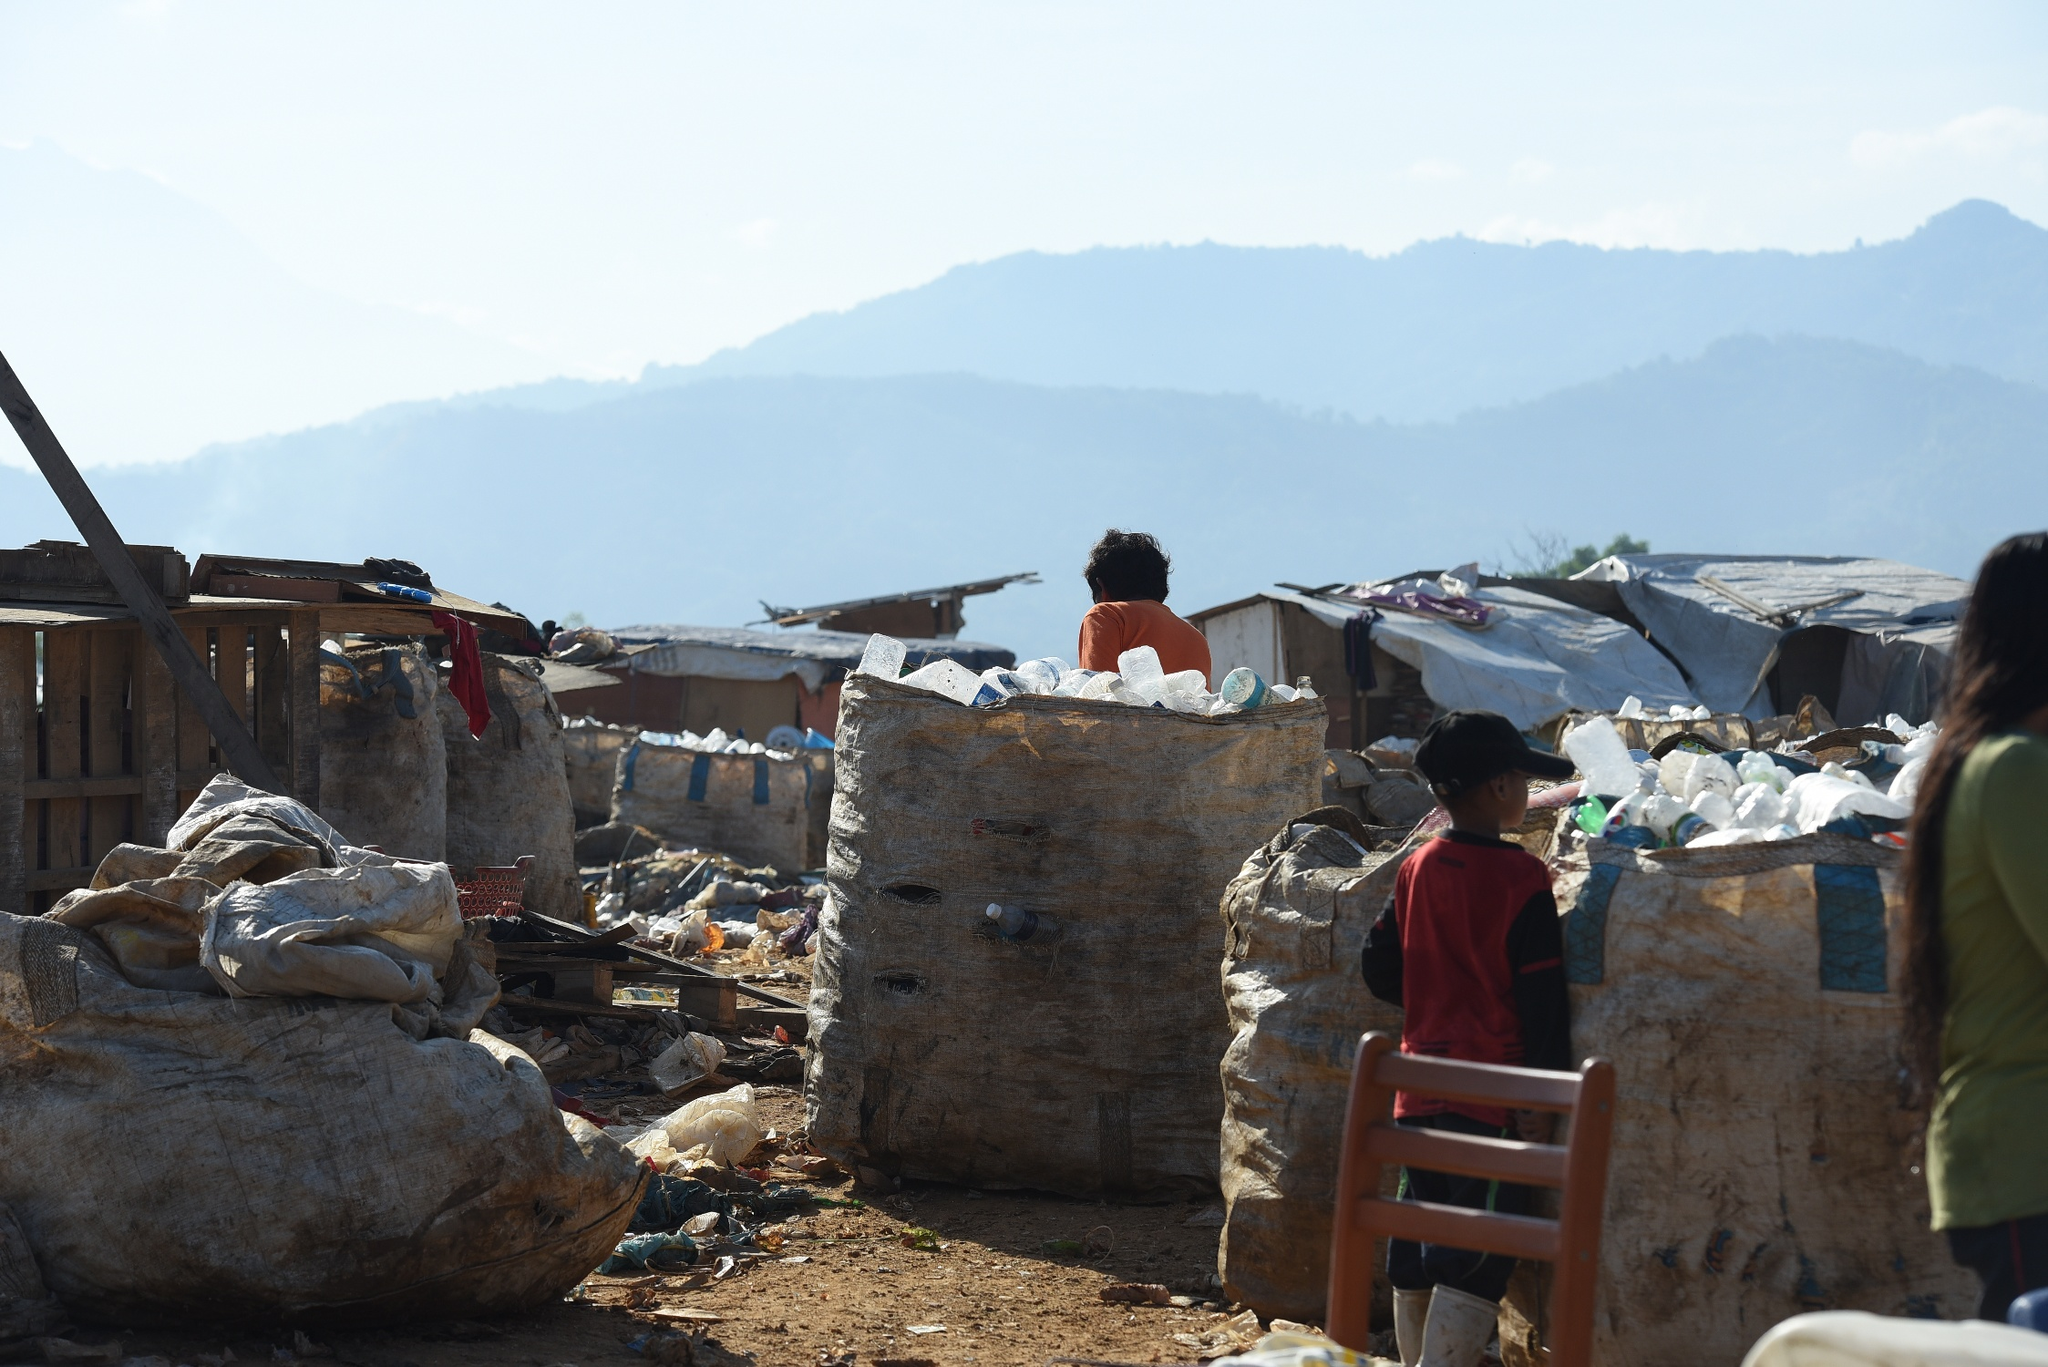Imagine a story where this child grows up and becomes a renowned environmental activist. How did their journey begin? The story begins with a young child, standing in silent contemplation beside a massive pile of discarded plastic bottles on a landfill that was once a green meadow. Witnessing the stark contrast between the serene mountains in the background and the harsh reality of the garbage-laden foreground instilled a deep sense of responsibility in the child. As they grew older, their curiosity about the causes and consequences of such environmental degradation intensified. Despite the lack of resources, the child found solace in the library's few books on nature and conservation. The defining moment came during a community clean-up drive led by a visiting environmental activist, whose stories about restoring polluted rivers inspired the child. This experience ignited a passion for environmental advocacy that saw them organizing local clean-up initiatives, campaigning for municipal recycling programs, and eventually studying environmental science. Their relentless determination and innovative approaches to waste management earned them national recognition, transforming them into a renowned environmental activist dedicated to healing the planet. As an adult activist, what significant achievements did this person accomplish? As an adult, the once curious child became a leading figure in the fight against environmental degradation, with several significant achievements to their name. They spearheaded the establishment of a nationwide plastic recycling program that drastically reduced waste in landfills. Their most notable campaign led to the clean-up and revitalization of a heavily polluted river, turning it back into a thriving ecosystem teeming with wildlife. Their advocacy work resulted in stricter environmental regulations, ensuring industries adopted greener practices and minimizing their ecological footprints. They also founded an NGO that educated communities about sustainable living and supported young aspiring environmentalists. Their efforts garnered international recognition, inspiring millions to take action in their own communities and fostering a global movement towards a more sustainable future. 